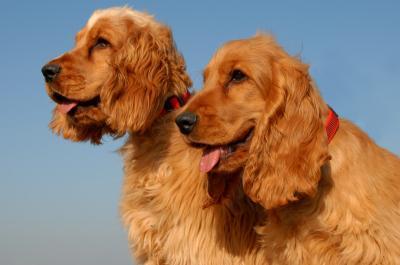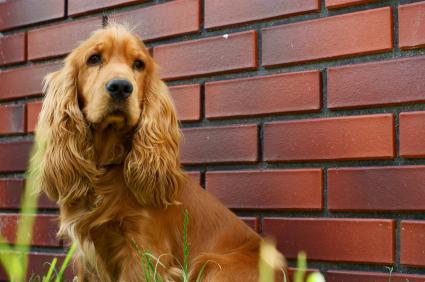The first image is the image on the left, the second image is the image on the right. For the images shown, is this caption "All dogs wear a leash or collar." true? Answer yes or no. No. The first image is the image on the left, the second image is the image on the right. Considering the images on both sides, is "An image shows exactly two red-orange dogs side-by-side." valid? Answer yes or no. Yes. 